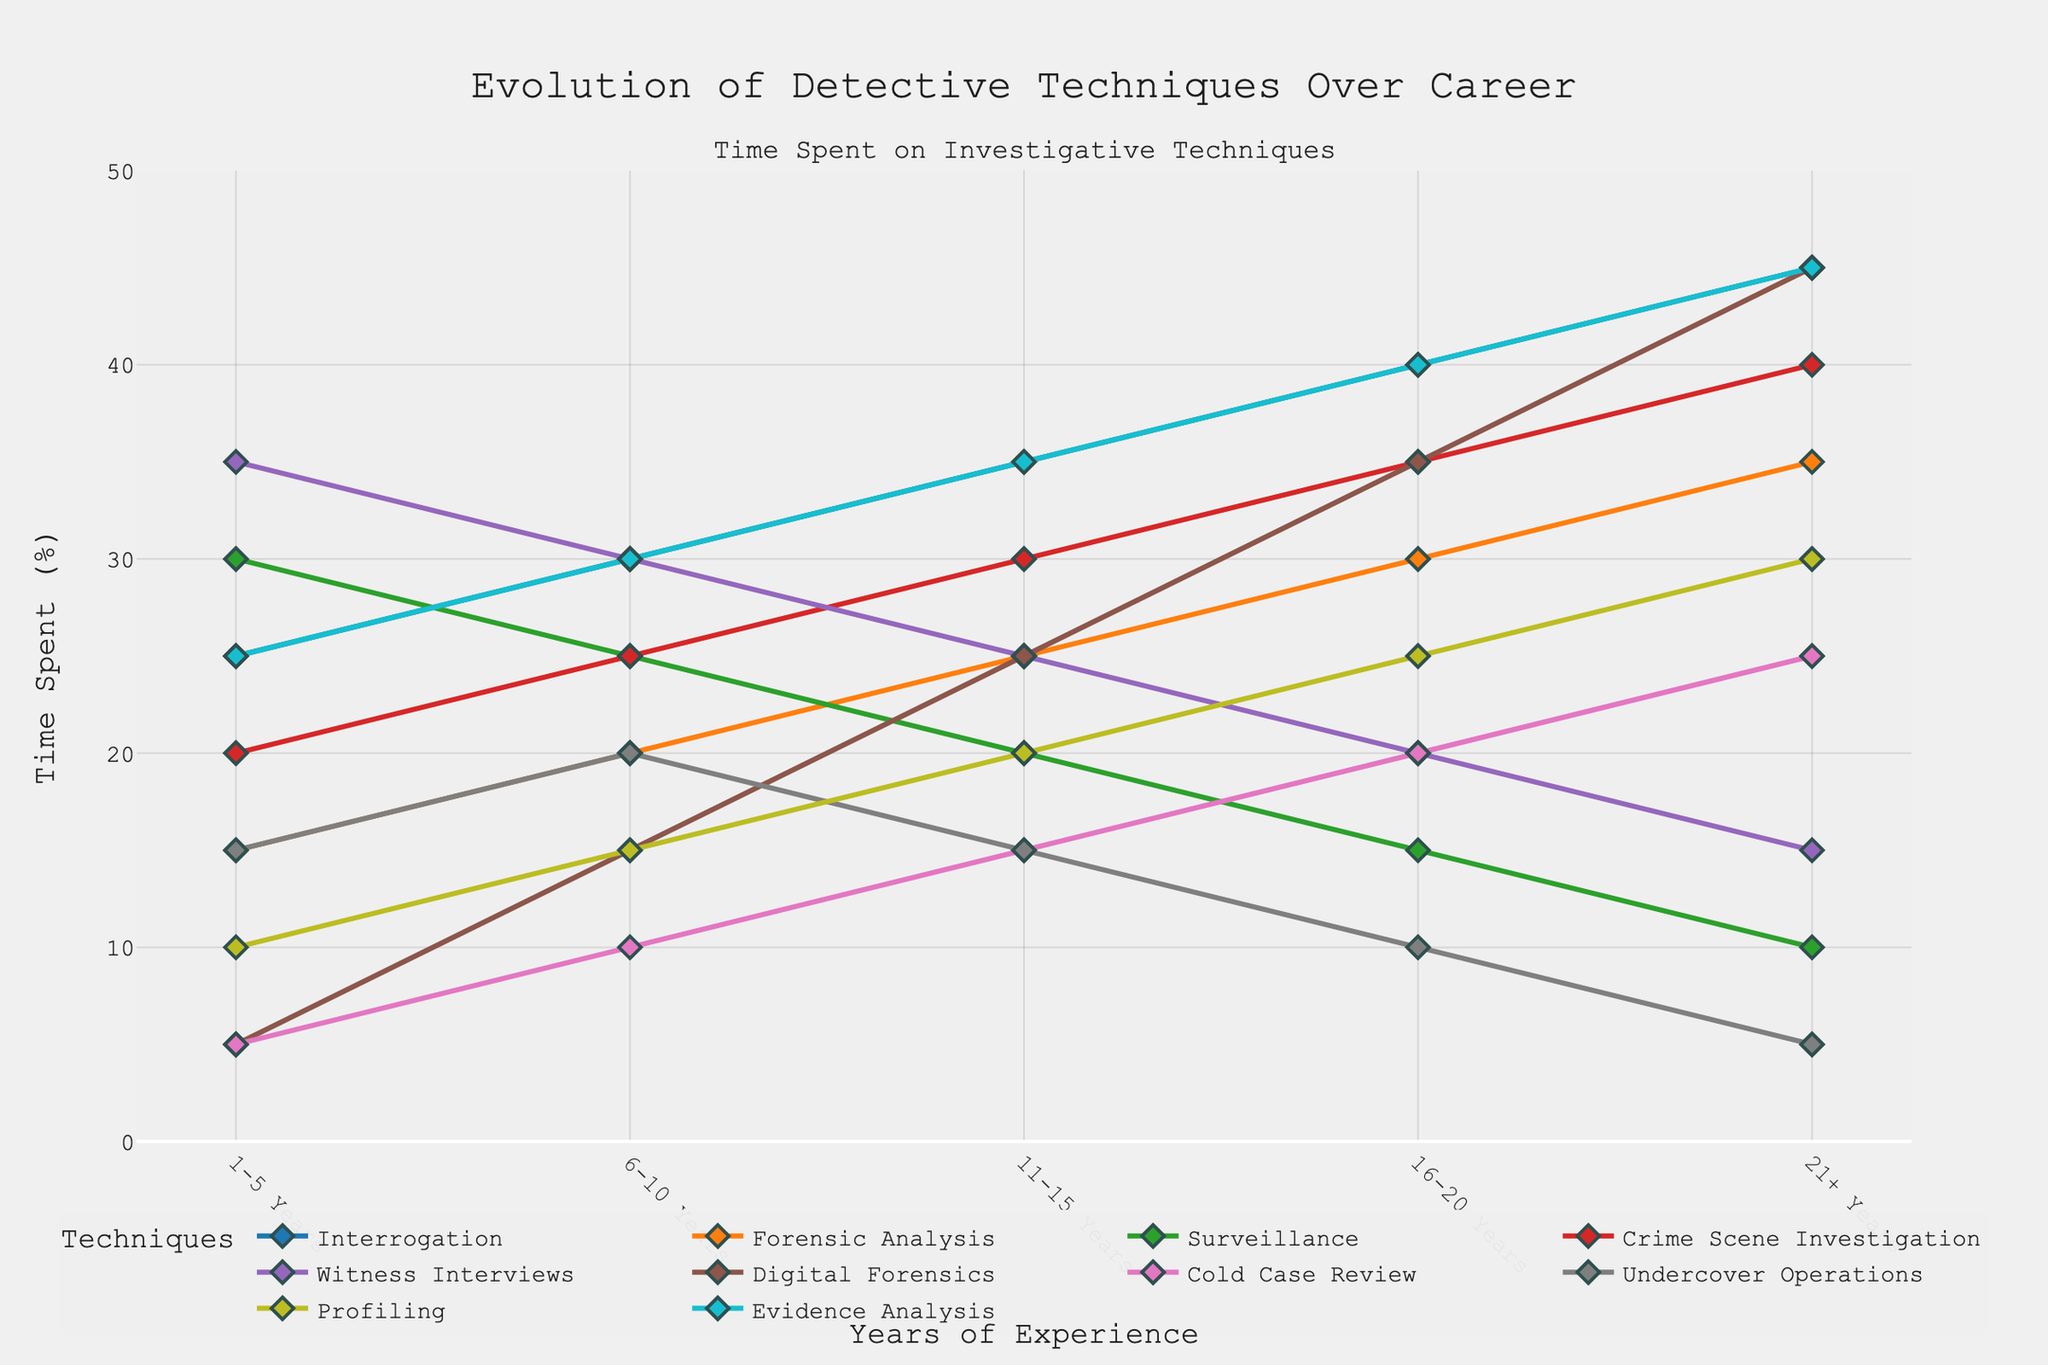Which technique sees an overall decrease in time spent from 1-5 years to 21+ years? To find the technique with an overall decrease, look at each line's trend from the start to the end point. Only Surveillance and Witness Interviews show an overall decrease in time spent.
Answer: Surveillance, Witness Interviews Which technique's time spent begins at 5% and increases steadily to 45% over the career span? Follow the line that starts at 5% and look for a steady increase until it reaches 45% at the end. Digital Forensics fits this pattern.
Answer: Digital Forensics Name two techniques where the time spent stabilizes at around 45% towards the end of the careers. Identify lines that approach and maintain a 45% time spent at the end of the x-axis (21+ Years). Interrogation and Evidence Analysis both stabilize at around 45%.
Answer: Interrogation, Evidence Analysis Which technique's time spent peaks at 20% within the first 10 years and then decreases steadily? Find the technique whose line increases to 20% by 6-10 years and then decreases. Undercover Operations increases to 20% by 6-10 years and then decreases.
Answer: Undercover Operations Compare the time spent on Forensic Analysis and Crime Scene Investigation in the 1-5 years range. Which technique has a higher percentage? Look at the start of the line chart, find the values for Forensic Analysis and Crime Scene Investigation in the 1-5 years range. Forensic Analysis is at 15% and Crime Scene Investigation is at 20%.
Answer: Crime Scene Investigation Calculate the average time spent on Profiling for the 16-20 years and 21+ years periods. For Profiling, add the values at 16-20 years (25%) and 21+ years (30%), then divide by 2. (25 + 30) / 2 = 27.5%.
Answer: 27.5% Which two techniques have overlapping lines (the same values) at any year range? To identify overlapping lines, look for lines that intersect or share the same y-values. Evidence Analysis and Interrogation overlap at 1-5 years (both at 25%) and again at 21+ years (both at 45%).
Answer: Evidence Analysis, Interrogation By how much does the time spent on Cold Case Review increase from the 1-5 years range to the 21+ years range? Find the time spent on Cold Case Review at 1-5 years (5%) and at 21+ years (25%). Subtract the former from the latter: 25% - 5% = 20%.
Answer: 20% Which technique has a steady increase of exactly 5% per career stage? Look for a technique where each year's percentage increases by a consistent 5%. Forensic Analysis increases by 5% at each stage from 15% to 35%.
Answer: Forensic Analysis 